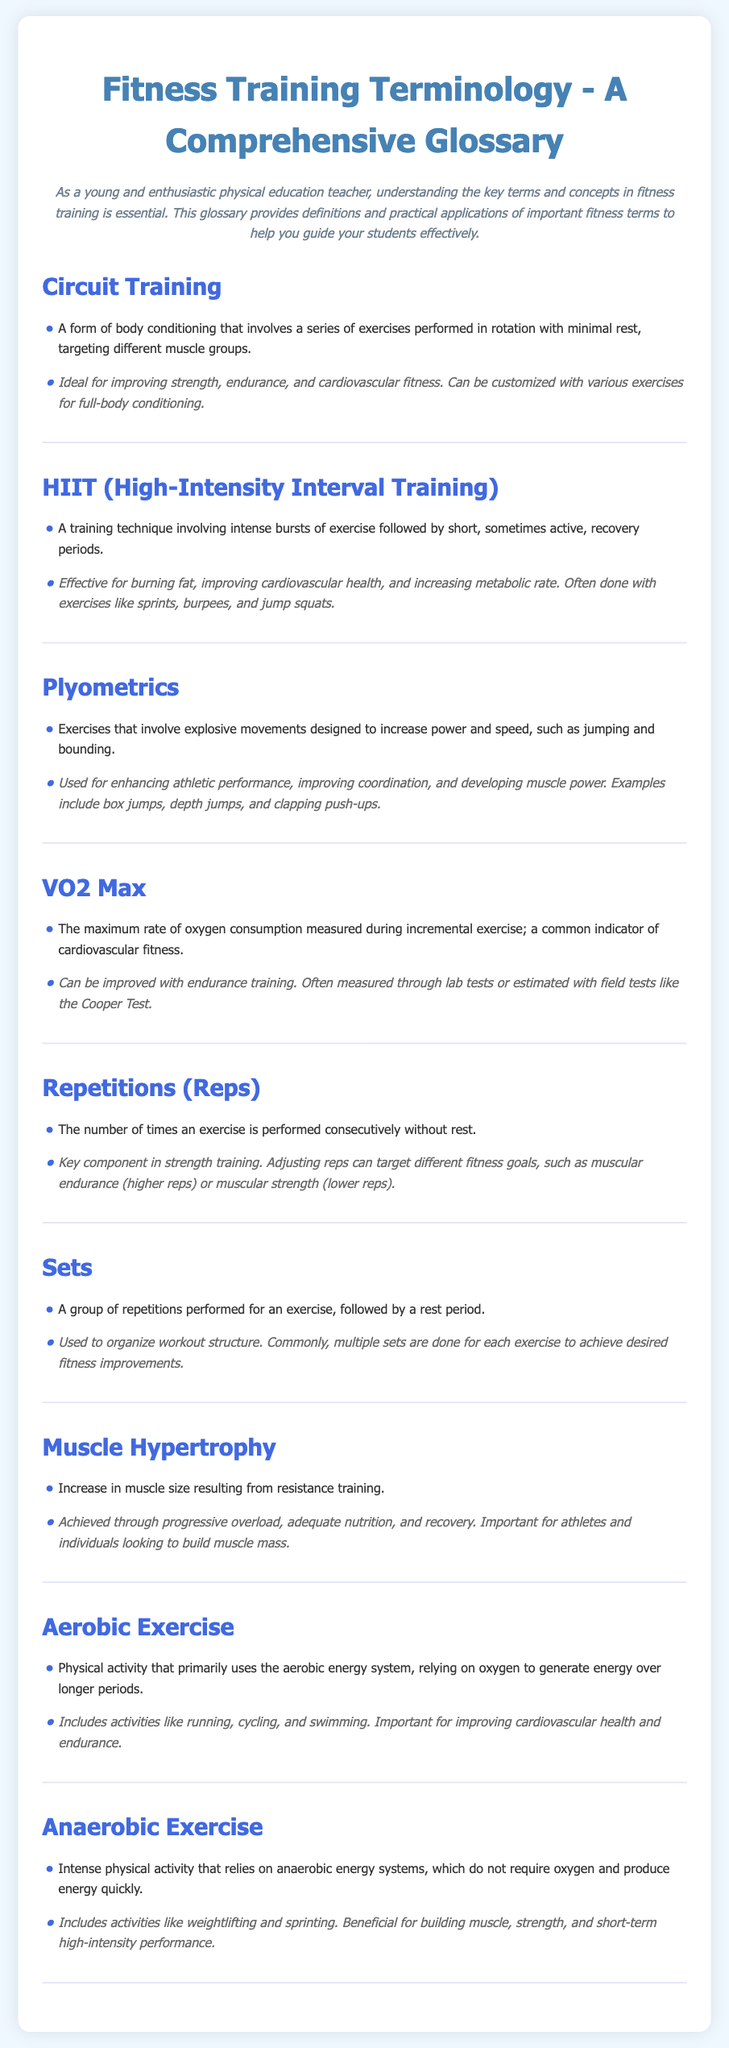What is Circuit Training? Circuit Training is defined as a form of body conditioning that involves a series of exercises performed in rotation with minimal rest.
Answer: A form of body conditioning What does HIIT stand for? HIIT is an acronym that stands for High-Intensity Interval Training.
Answer: High-Intensity Interval Training What is the application of Plyometrics? The application of Plyometrics includes enhancing athletic performance, improving coordination, and developing muscle power.
Answer: Enhancing athletic performance What is VO2 Max? VO2 Max is defined as the maximum rate of oxygen consumption measured during incremental exercise.
Answer: Maximum rate of oxygen consumption What is the primary focus of Aerobic Exercise? The primary focus of Aerobic Exercise is to primarily use the aerobic energy system, relying on oxygen to generate energy over longer periods.
Answer: Use the aerobic energy system What type of exercise relies on anaerobic energy systems? Anaerobic Exercise is the type of exercise that relies on anaerobic energy systems, which do not require oxygen.
Answer: Anaerobic Exercise How can Muscle Hypertrophy be achieved? Muscle Hypertrophy can be achieved through progressive overload, adequate nutrition, and recovery.
Answer: Progressive overload, nutrition, recovery What are Repetitions (Reps)? Repetitions (Reps) refer to the number of times an exercise is performed consecutively without rest.
Answer: Number of times an exercise is performed What is the role of a Set in fitness training? A Set is defined as a group of repetitions performed for an exercise, followed by a rest period.
Answer: Group of repetitions 